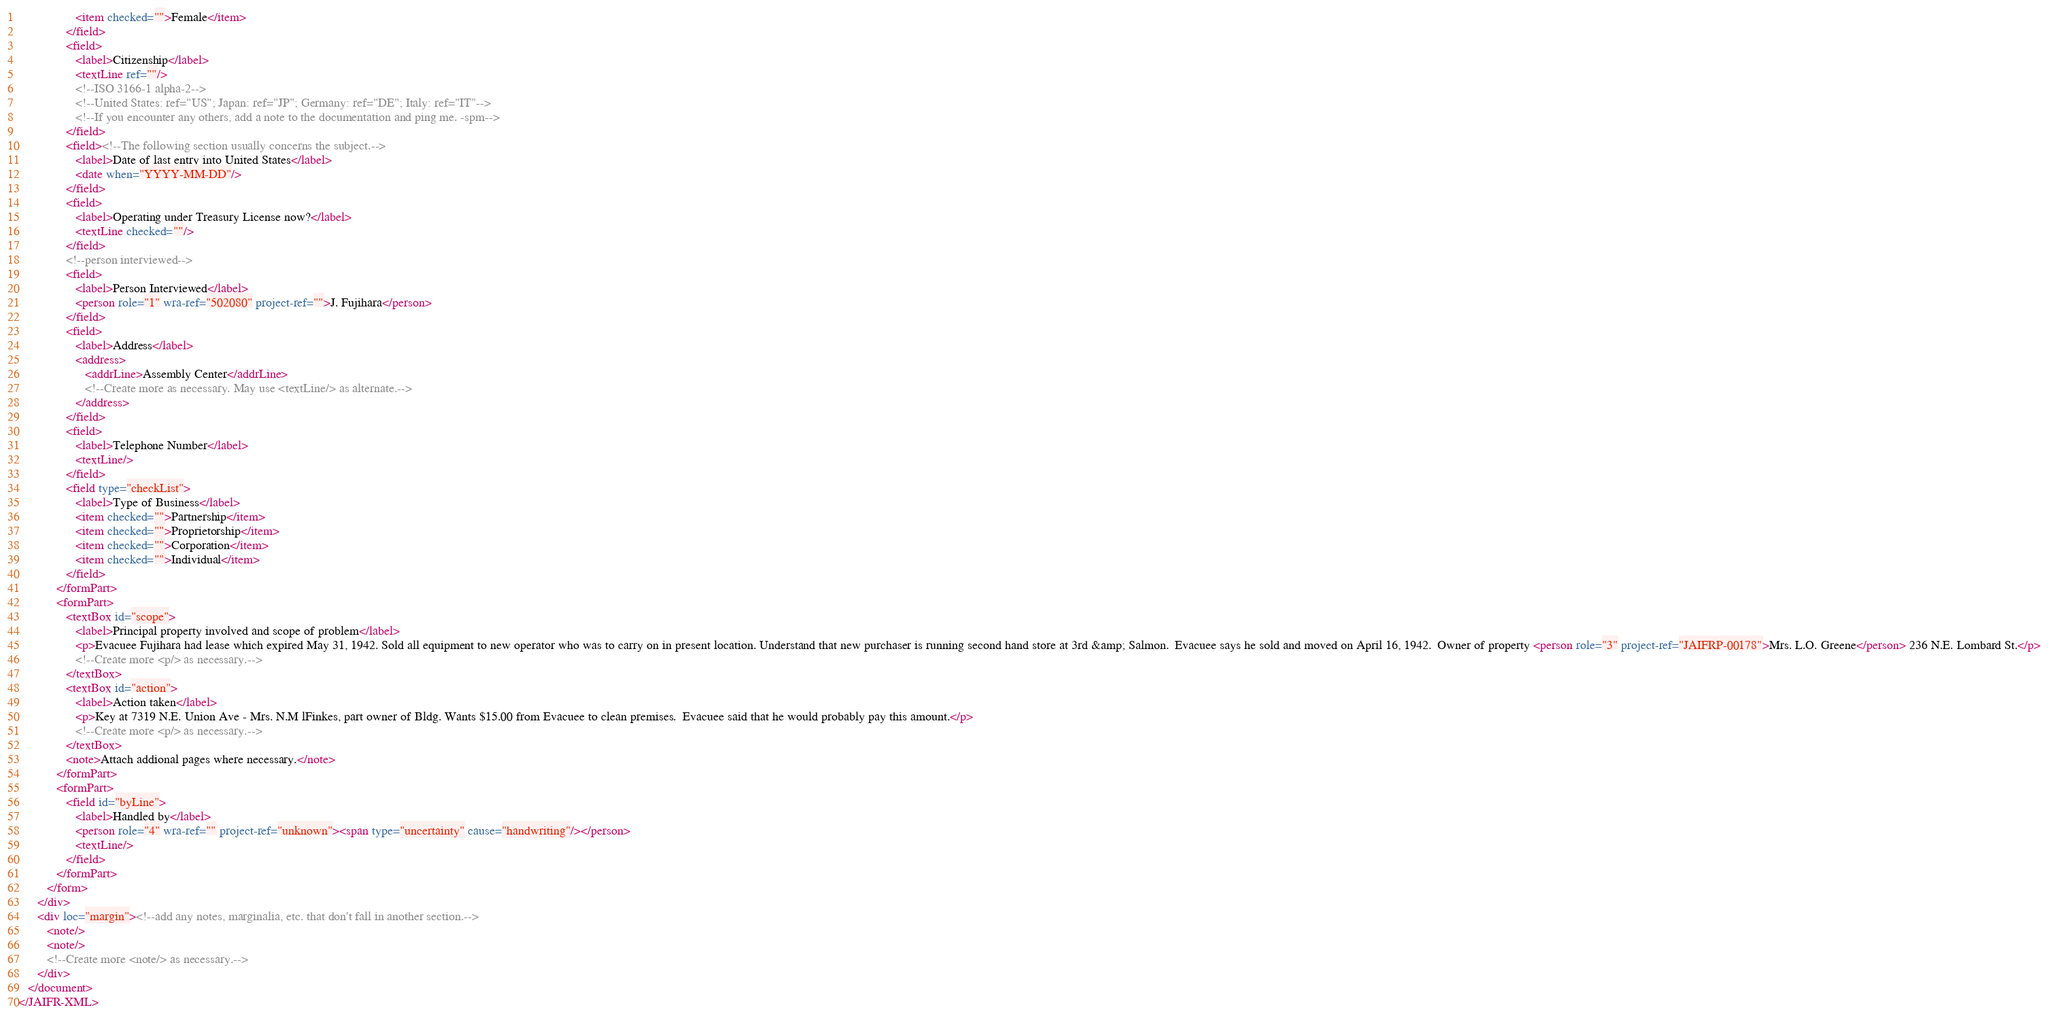<code> <loc_0><loc_0><loc_500><loc_500><_XML_>                  <item checked="">Female</item>
               </field>
               <field>
                  <label>Citizenship</label>
                  <textLine ref=""/>
                  <!--ISO 3166-1 alpha-2-->
                  <!--United States: ref="US"; Japan: ref="JP"; Germany: ref="DE"; Italy: ref="IT"-->
                  <!--If you encounter any others, add a note to the documentation and ping me. -spm-->
               </field>
               <field><!--The following section usually concerns the subject.-->
                  <label>Date of last entry into United States</label>
                  <date when="YYYY-MM-DD"/>
               </field>
               <field>
                  <label>Operating under Treasury License now?</label>
                  <textLine checked=""/>
               </field>
               <!--person interviewed-->
               <field>
                  <label>Person Interviewed</label>
                  <person role="1" wra-ref="502080" project-ref="">J. Fujihara</person>
               </field>
               <field>
                  <label>Address</label>
                  <address>
                     <addrLine>Assembly Center</addrLine>
                     <!--Create more as necessary. May use <textLine/> as alternate.-->
                  </address>
               </field>
               <field>
                  <label>Telephone Number</label>
                  <textLine/>
               </field>
               <field type="checkList">
                  <label>Type of Business</label>
                  <item checked="">Partnership</item>
                  <item checked="">Proprietorship</item>
                  <item checked="">Corporation</item>
                  <item checked="">Individual</item>
               </field>
            </formPart>
            <formPart>
               <textBox id="scope">
                  <label>Principal property involved and scope of problem</label>
                  <p>Evacuee Fujihara had lease which expired May 31, 1942. Sold all equipment to new operator who was to carry on in present location. Understand that new purchaser is running second hand store at 3rd &amp; Salmon.  Evacuee says he sold and moved on April 16, 1942.  Owner of property <person role="3" project-ref="JAIFRP-00178">Mrs. L.O. Greene</person> 236 N.E. Lombard St.</p>
                  <!--Create more <p/> as necessary.-->
               </textBox>
               <textBox id="action">
                  <label>Action taken</label>
                  <p>Key at 7319 N.E. Union Ave - Mrs. N.M lFinkes, part owner of Bldg. Wants $15.00 from Evacuee to clean premises.  Evacuee said that he would probably pay this amount.</p>
                  <!--Create more <p/> as necessary.-->
               </textBox>
               <note>Attach addional pages where necessary.</note>
            </formPart>
            <formPart>
               <field id="byLine">
                  <label>Handled by</label>
                  <person role="4" wra-ref="" project-ref="unknown"><span type="uncertainty" cause="handwriting"/></person>
                  <textLine/>
               </field>
            </formPart>
         </form>
      </div>
      <div loc="margin"><!--add any notes, marginalia, etc. that don't fall in another section.-->
         <note/>
         <note/>
         <!--Create more <note/> as necessary.-->
      </div>
   </document>
</JAIFR-XML>
</code> 